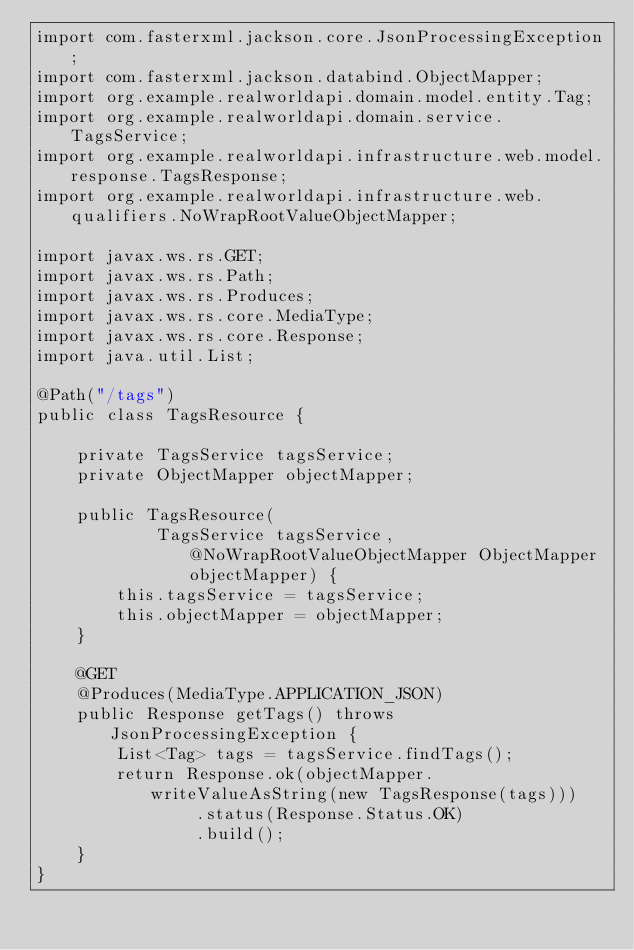<code> <loc_0><loc_0><loc_500><loc_500><_Java_>import com.fasterxml.jackson.core.JsonProcessingException;
import com.fasterxml.jackson.databind.ObjectMapper;
import org.example.realworldapi.domain.model.entity.Tag;
import org.example.realworldapi.domain.service.TagsService;
import org.example.realworldapi.infrastructure.web.model.response.TagsResponse;
import org.example.realworldapi.infrastructure.web.qualifiers.NoWrapRootValueObjectMapper;

import javax.ws.rs.GET;
import javax.ws.rs.Path;
import javax.ws.rs.Produces;
import javax.ws.rs.core.MediaType;
import javax.ws.rs.core.Response;
import java.util.List;

@Path("/tags")
public class TagsResource {

    private TagsService tagsService;
    private ObjectMapper objectMapper;

    public TagsResource(
            TagsService tagsService, @NoWrapRootValueObjectMapper ObjectMapper objectMapper) {
        this.tagsService = tagsService;
        this.objectMapper = objectMapper;
    }

    @GET
    @Produces(MediaType.APPLICATION_JSON)
    public Response getTags() throws JsonProcessingException {
        List<Tag> tags = tagsService.findTags();
        return Response.ok(objectMapper.writeValueAsString(new TagsResponse(tags)))
                .status(Response.Status.OK)
                .build();
    }
}
</code> 